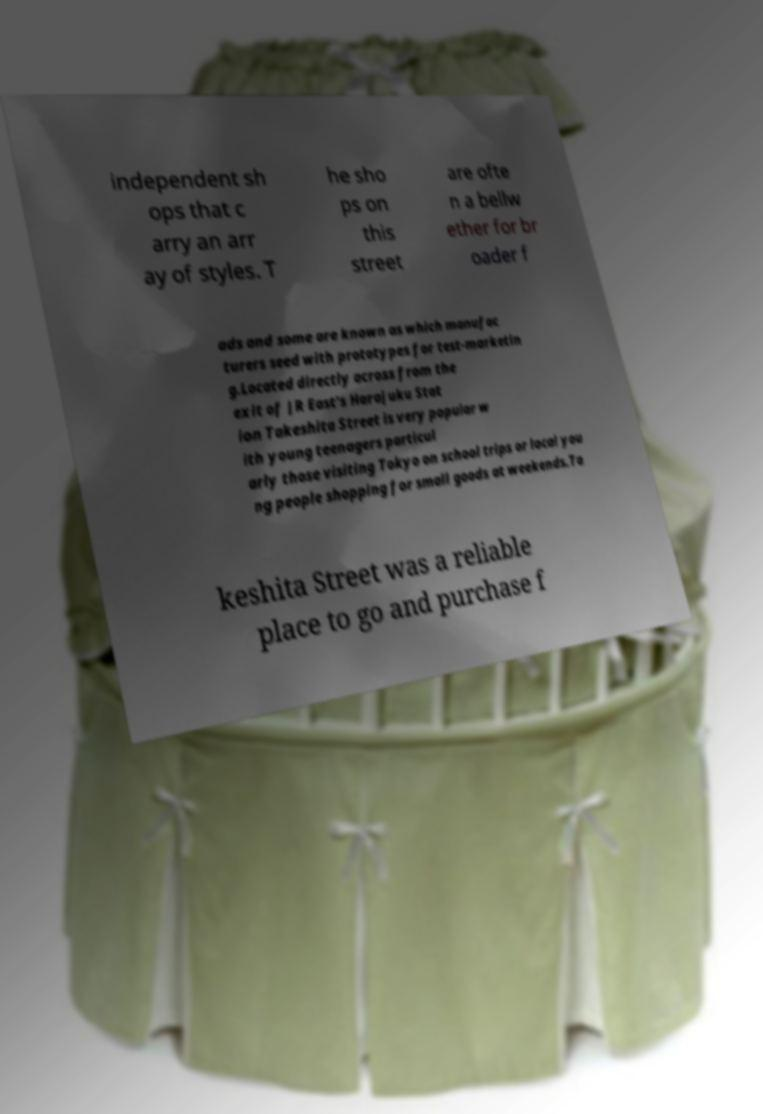For documentation purposes, I need the text within this image transcribed. Could you provide that? independent sh ops that c arry an arr ay of styles. T he sho ps on this street are ofte n a bellw ether for br oader f ads and some are known as which manufac turers seed with prototypes for test-marketin g.Located directly across from the exit of JR East's Harajuku Stat ion Takeshita Street is very popular w ith young teenagers particul arly those visiting Tokyo on school trips or local you ng people shopping for small goods at weekends.Ta keshita Street was a reliable place to go and purchase f 